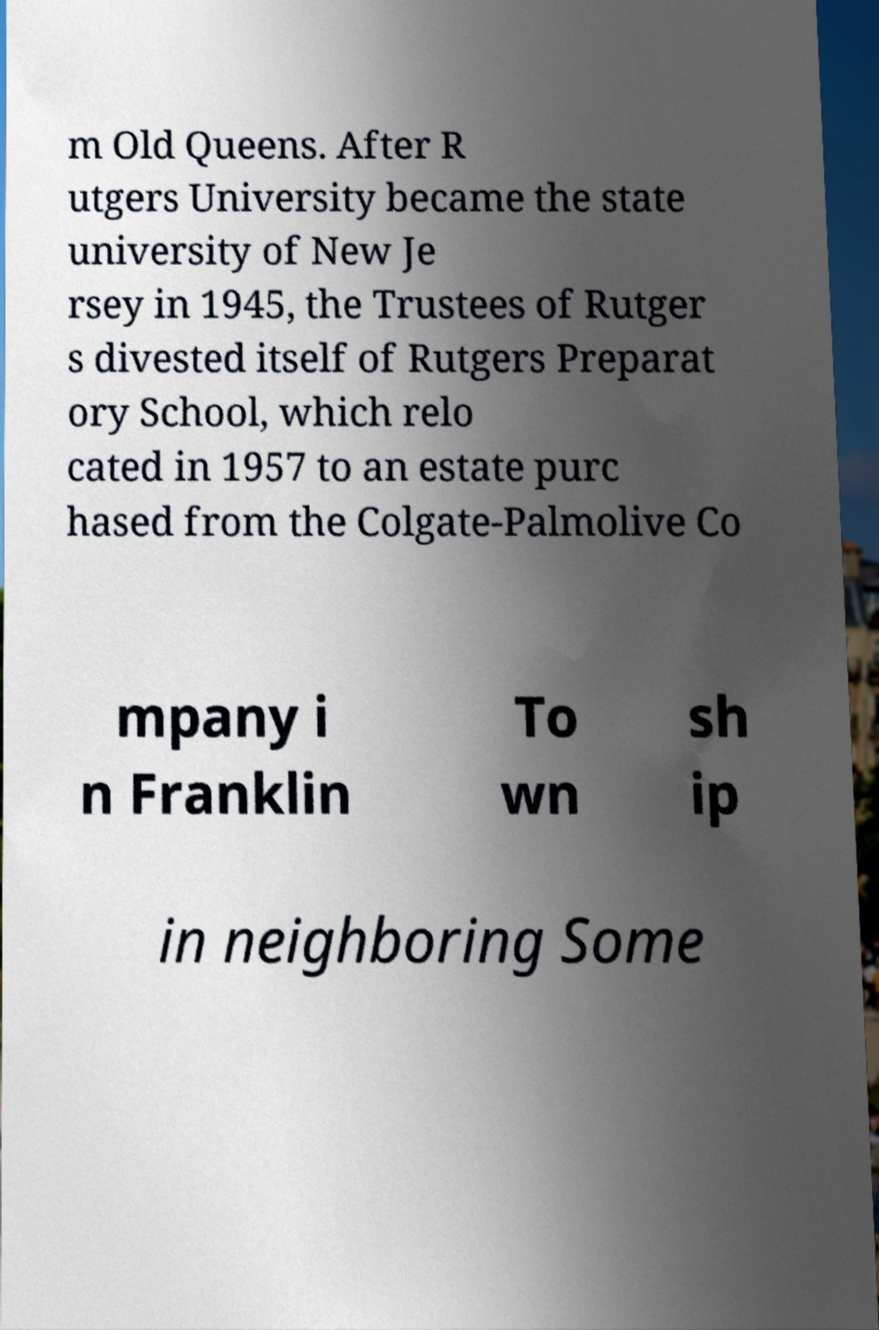Could you extract and type out the text from this image? m Old Queens. After R utgers University became the state university of New Je rsey in 1945, the Trustees of Rutger s divested itself of Rutgers Preparat ory School, which relo cated in 1957 to an estate purc hased from the Colgate-Palmolive Co mpany i n Franklin To wn sh ip in neighboring Some 